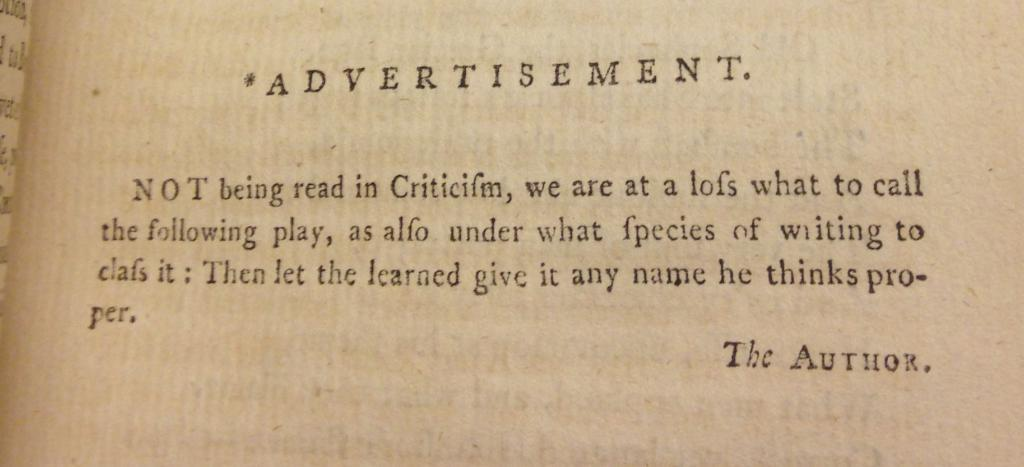<image>
Present a compact description of the photo's key features. A page in a book says Advertisement with a note by the author. 